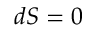Convert formula to latex. <formula><loc_0><loc_0><loc_500><loc_500>d S = 0</formula> 